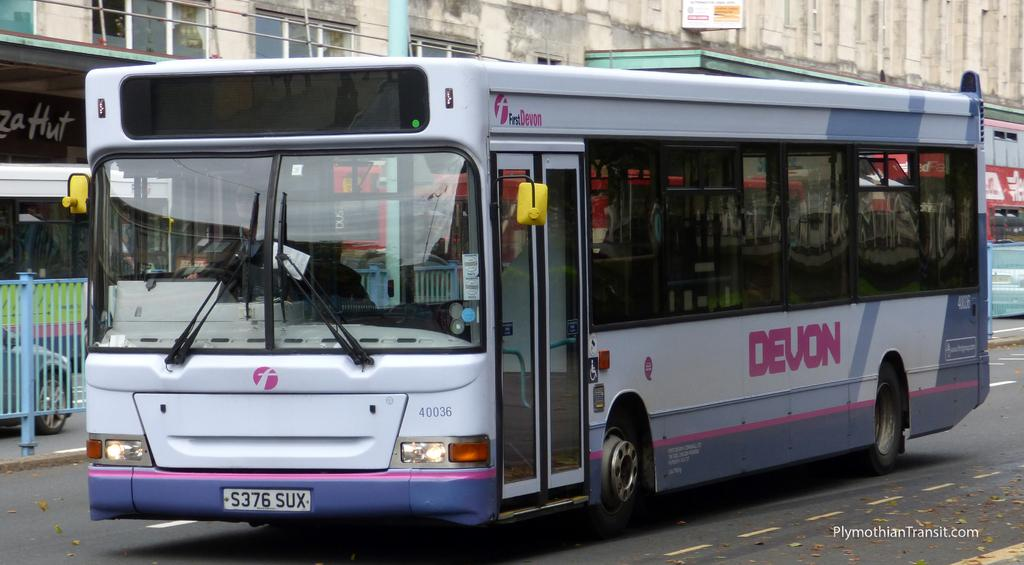<image>
Give a short and clear explanation of the subsequent image. A white and purple Devon bus is going down a city street. 